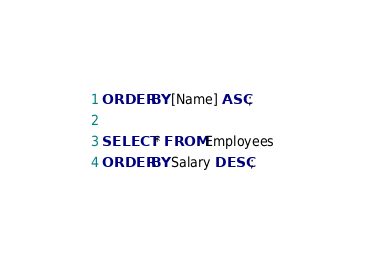Convert code to text. <code><loc_0><loc_0><loc_500><loc_500><_SQL_>ORDER BY [Name] ASC;

SELECT * FROM Employees
ORDER BY Salary DESC;</code> 